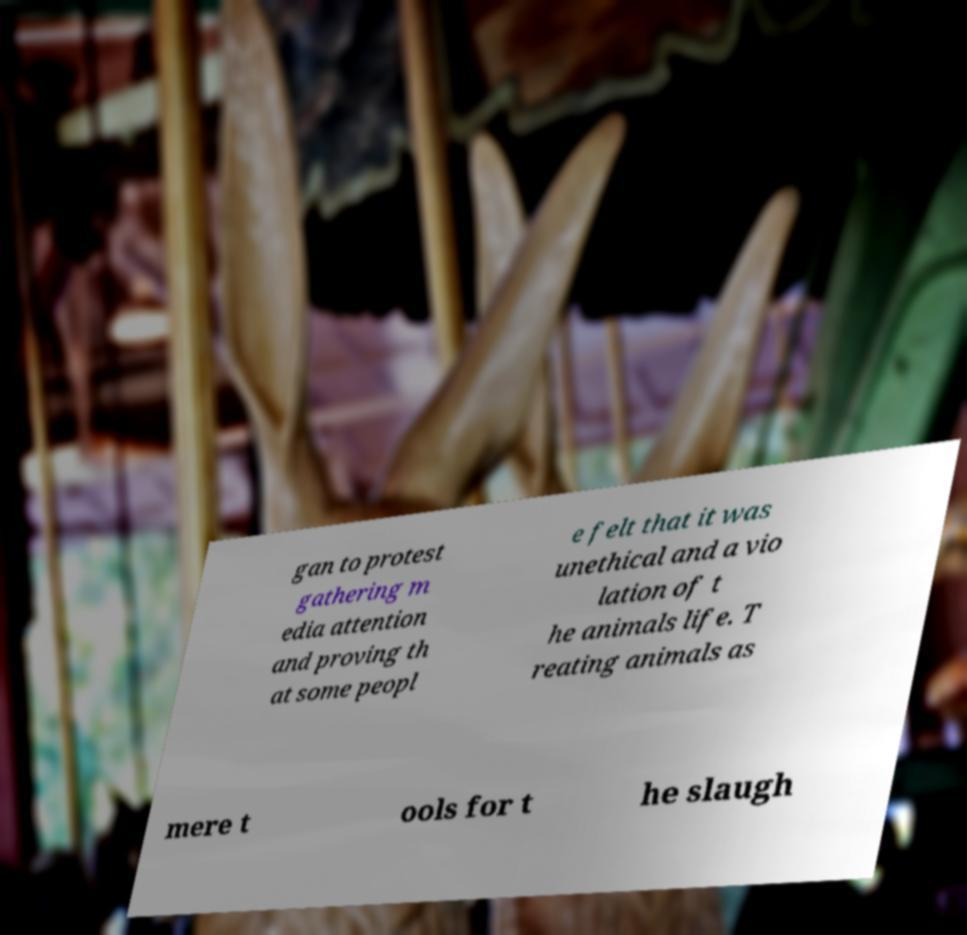Can you read and provide the text displayed in the image?This photo seems to have some interesting text. Can you extract and type it out for me? gan to protest gathering m edia attention and proving th at some peopl e felt that it was unethical and a vio lation of t he animals life. T reating animals as mere t ools for t he slaugh 